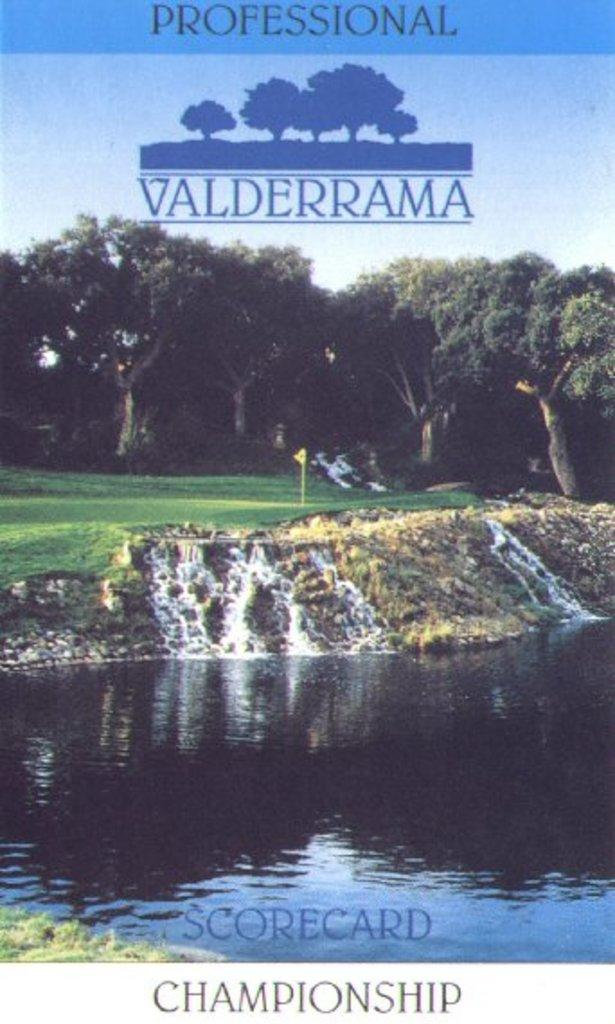<image>
Give a short and clear explanation of the subsequent image. The cover of a golf scorecard for the Professional Valderrama championship. 